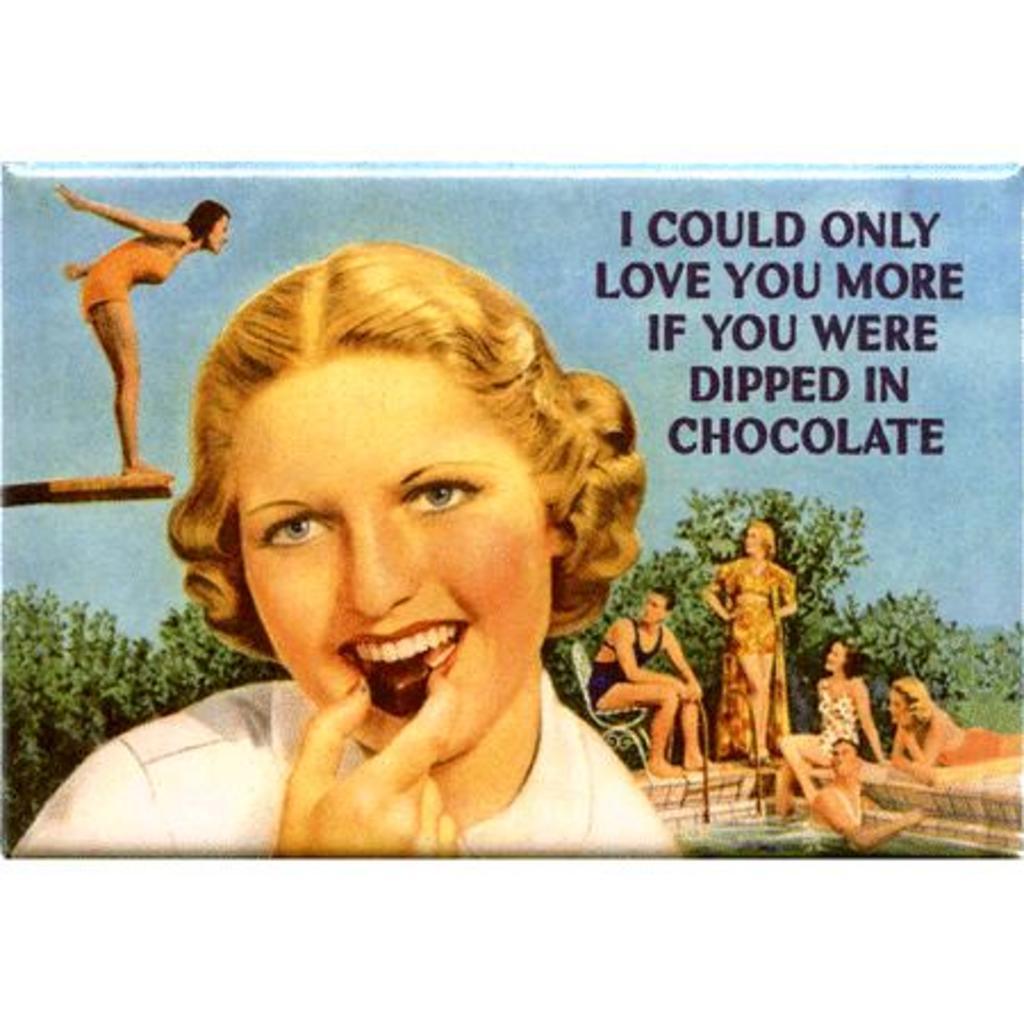Can you describe this image briefly? There is a poster. In which, there is a woman in white shirt, eating a food item. Beside her, there is a person on the platform and there is a person in a swimming pool. Beside him, there are other persons. In the background, there are trees and there is sky. 